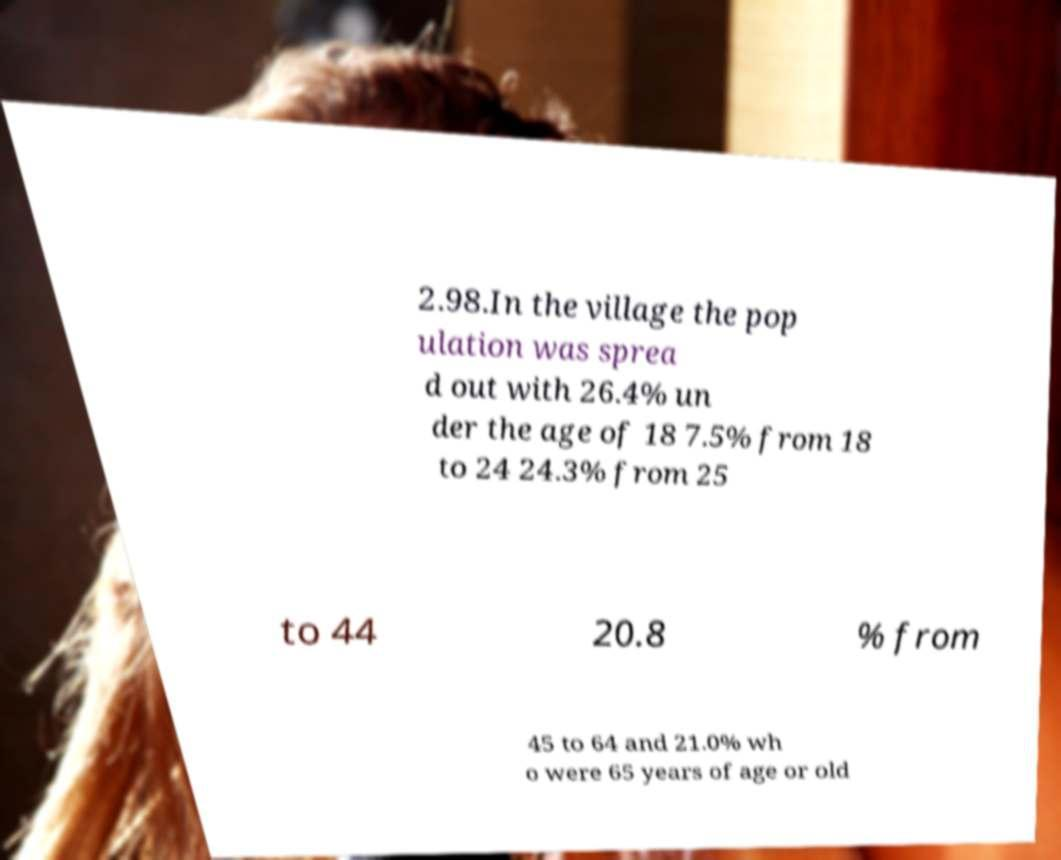I need the written content from this picture converted into text. Can you do that? 2.98.In the village the pop ulation was sprea d out with 26.4% un der the age of 18 7.5% from 18 to 24 24.3% from 25 to 44 20.8 % from 45 to 64 and 21.0% wh o were 65 years of age or old 